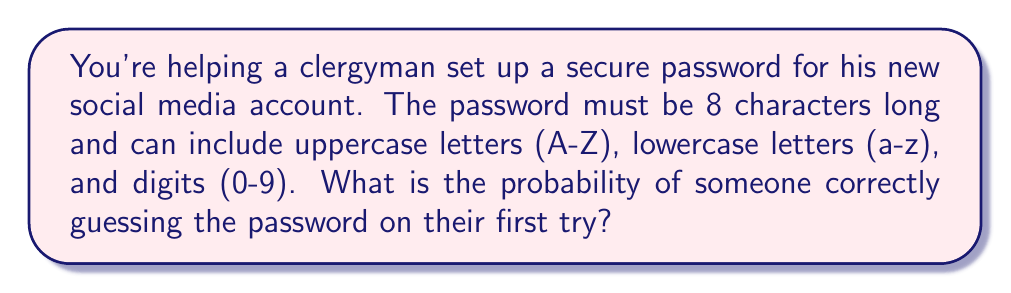What is the answer to this math problem? Let's approach this step-by-step:

1) First, we need to determine the total number of possible characters:
   - 26 uppercase letters
   - 26 lowercase letters
   - 10 digits
   Total: 26 + 26 + 10 = 62 possible characters

2) For each character position, there are 62 choices.

3) The password is 8 characters long, so we need to calculate the total number of possible passwords.

4) This is a case of independent events, where each character selection is independent of the others. We use the multiplication principle of counting.

5) The total number of possible passwords is:

   $$ 62^8 $$

6) The probability of guessing the correct password on the first try is 1 divided by the total number of possible passwords:

   $$ P(\text{correct guess}) = \frac{1}{62^8} $$

7) To calculate this:

   $$ P(\text{correct guess}) = \frac{1}{62^8} \approx 2.6 \times 10^{-15} $$

This extremely small probability demonstrates why long passwords with a diverse character set are considered secure.
Answer: $\frac{1}{62^8}$ or approximately $2.6 \times 10^{-15}$ 